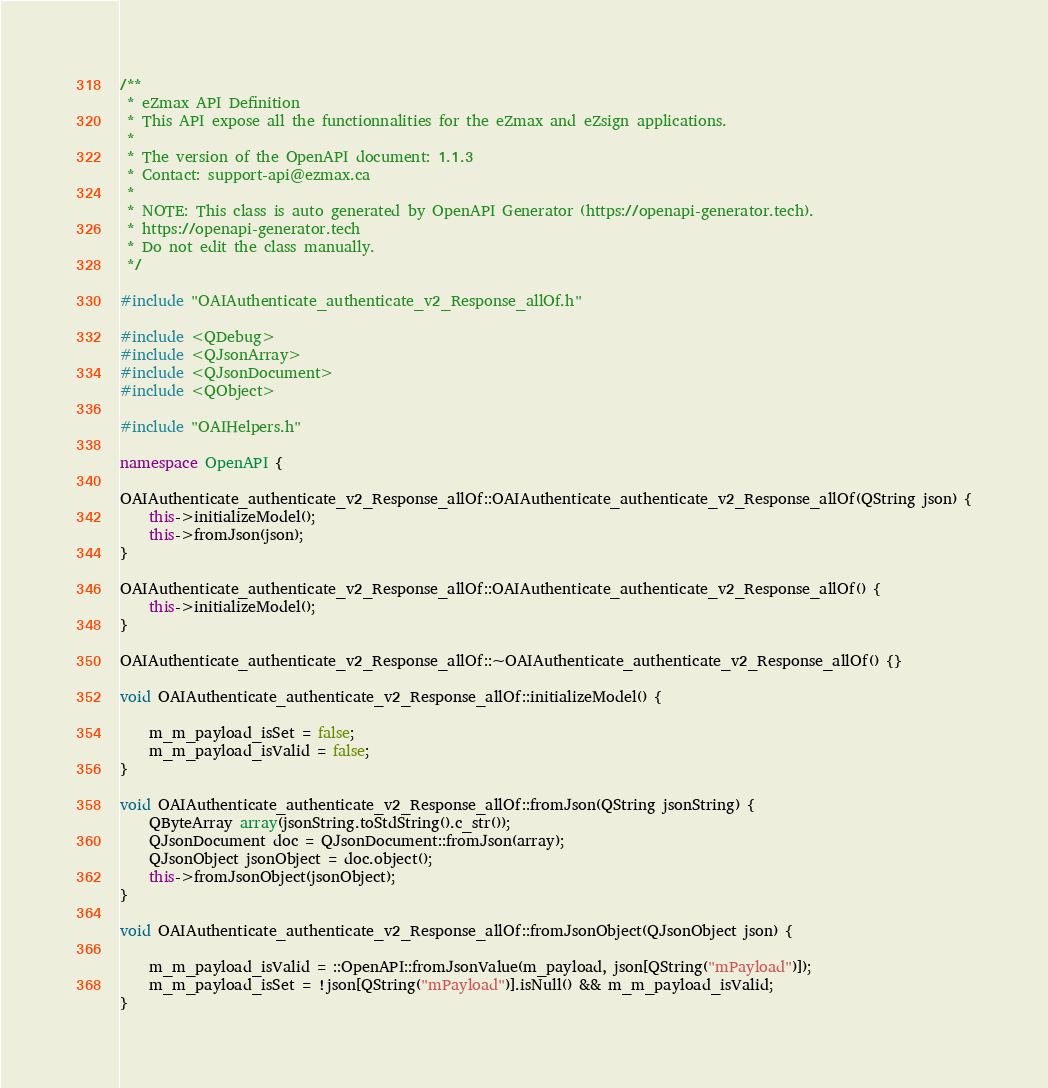<code> <loc_0><loc_0><loc_500><loc_500><_C++_>/**
 * eZmax API Definition
 * This API expose all the functionnalities for the eZmax and eZsign applications.
 *
 * The version of the OpenAPI document: 1.1.3
 * Contact: support-api@ezmax.ca
 *
 * NOTE: This class is auto generated by OpenAPI Generator (https://openapi-generator.tech).
 * https://openapi-generator.tech
 * Do not edit the class manually.
 */

#include "OAIAuthenticate_authenticate_v2_Response_allOf.h"

#include <QDebug>
#include <QJsonArray>
#include <QJsonDocument>
#include <QObject>

#include "OAIHelpers.h"

namespace OpenAPI {

OAIAuthenticate_authenticate_v2_Response_allOf::OAIAuthenticate_authenticate_v2_Response_allOf(QString json) {
    this->initializeModel();
    this->fromJson(json);
}

OAIAuthenticate_authenticate_v2_Response_allOf::OAIAuthenticate_authenticate_v2_Response_allOf() {
    this->initializeModel();
}

OAIAuthenticate_authenticate_v2_Response_allOf::~OAIAuthenticate_authenticate_v2_Response_allOf() {}

void OAIAuthenticate_authenticate_v2_Response_allOf::initializeModel() {

    m_m_payload_isSet = false;
    m_m_payload_isValid = false;
}

void OAIAuthenticate_authenticate_v2_Response_allOf::fromJson(QString jsonString) {
    QByteArray array(jsonString.toStdString().c_str());
    QJsonDocument doc = QJsonDocument::fromJson(array);
    QJsonObject jsonObject = doc.object();
    this->fromJsonObject(jsonObject);
}

void OAIAuthenticate_authenticate_v2_Response_allOf::fromJsonObject(QJsonObject json) {

    m_m_payload_isValid = ::OpenAPI::fromJsonValue(m_payload, json[QString("mPayload")]);
    m_m_payload_isSet = !json[QString("mPayload")].isNull() && m_m_payload_isValid;
}
</code> 